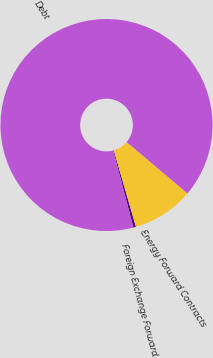<chart> <loc_0><loc_0><loc_500><loc_500><pie_chart><fcel>Foreign Exchange Forward<fcel>Energy Forward Contracts<fcel>Debt<nl><fcel>0.38%<fcel>9.37%<fcel>90.25%<nl></chart> 